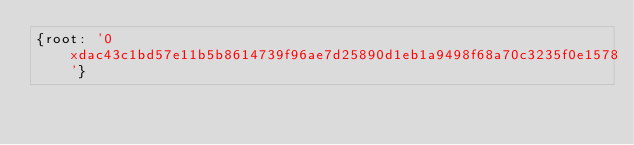Convert code to text. <code><loc_0><loc_0><loc_500><loc_500><_YAML_>{root: '0xdac43c1bd57e11b5b8614739f96ae7d25890d1eb1a9498f68a70c3235f0e1578'}
</code> 